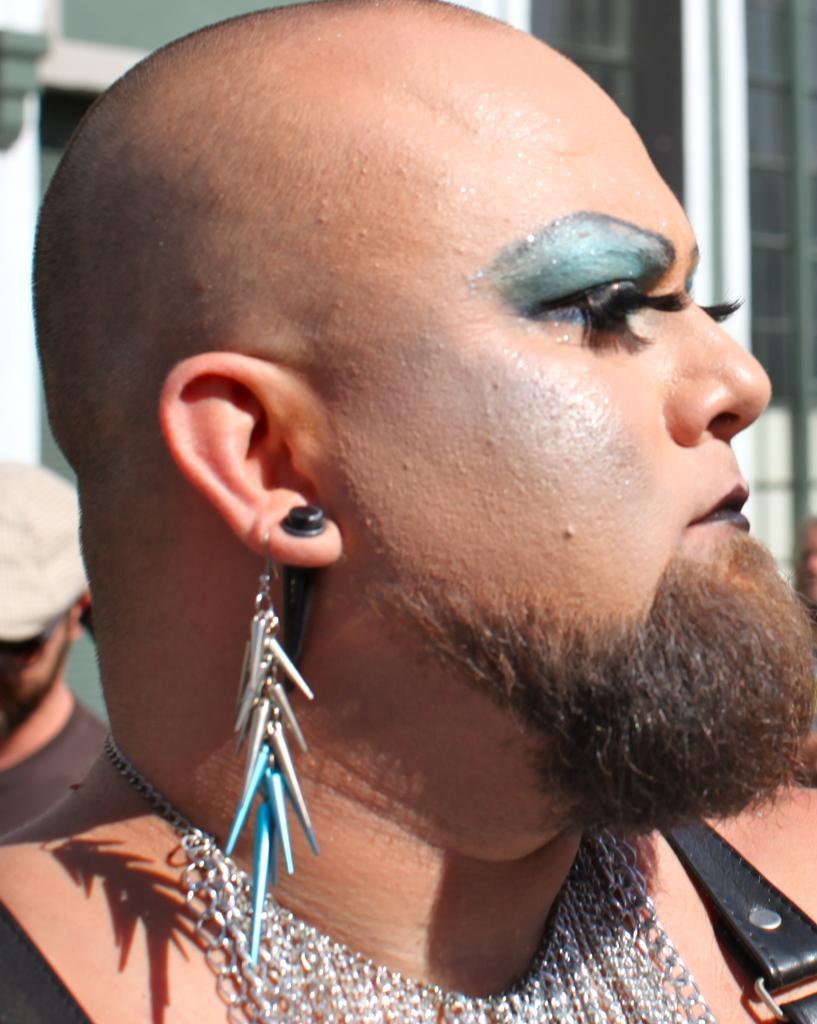In one or two sentences, can you explain what this image depicts? In this image in the foreground there is one person who is wearing earring, necklace. And in the background there are some persons and buildings. 